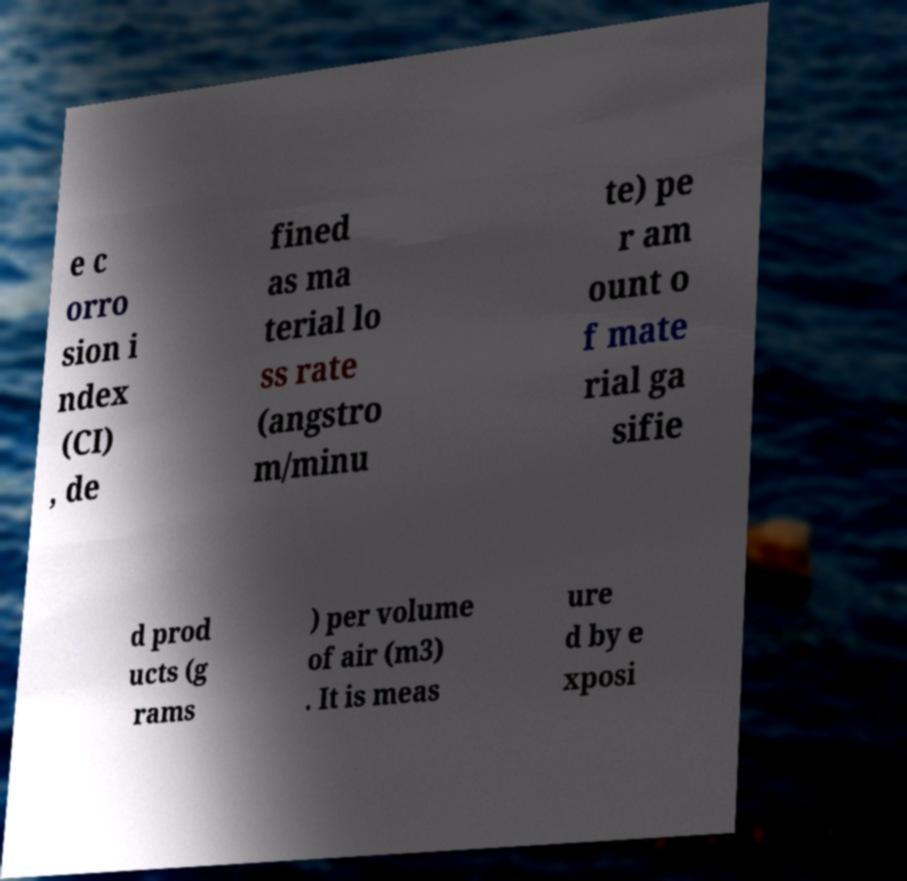Could you assist in decoding the text presented in this image and type it out clearly? e c orro sion i ndex (CI) , de fined as ma terial lo ss rate (angstro m/minu te) pe r am ount o f mate rial ga sifie d prod ucts (g rams ) per volume of air (m3) . It is meas ure d by e xposi 